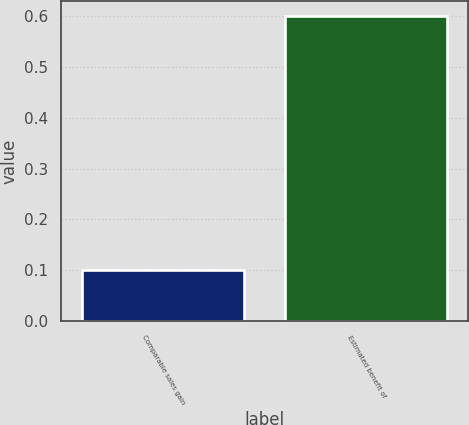Convert chart to OTSL. <chart><loc_0><loc_0><loc_500><loc_500><bar_chart><fcel>Comparable sales gain<fcel>Estimated benefit of<nl><fcel>0.1<fcel>0.6<nl></chart> 